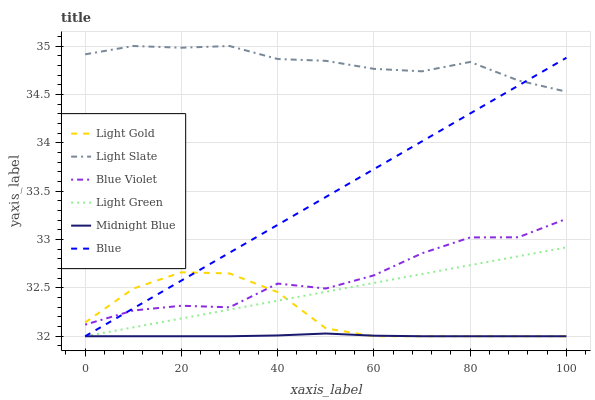Does Midnight Blue have the minimum area under the curve?
Answer yes or no. Yes. Does Light Slate have the maximum area under the curve?
Answer yes or no. Yes. Does Light Slate have the minimum area under the curve?
Answer yes or no. No. Does Midnight Blue have the maximum area under the curve?
Answer yes or no. No. Is Blue the smoothest?
Answer yes or no. Yes. Is Blue Violet the roughest?
Answer yes or no. Yes. Is Midnight Blue the smoothest?
Answer yes or no. No. Is Midnight Blue the roughest?
Answer yes or no. No. Does Light Slate have the lowest value?
Answer yes or no. No. Does Light Slate have the highest value?
Answer yes or no. Yes. Does Midnight Blue have the highest value?
Answer yes or no. No. Is Blue Violet less than Light Slate?
Answer yes or no. Yes. Is Light Slate greater than Light Green?
Answer yes or no. Yes. Does Blue Violet intersect Blue?
Answer yes or no. Yes. Is Blue Violet less than Blue?
Answer yes or no. No. Is Blue Violet greater than Blue?
Answer yes or no. No. Does Blue Violet intersect Light Slate?
Answer yes or no. No. 